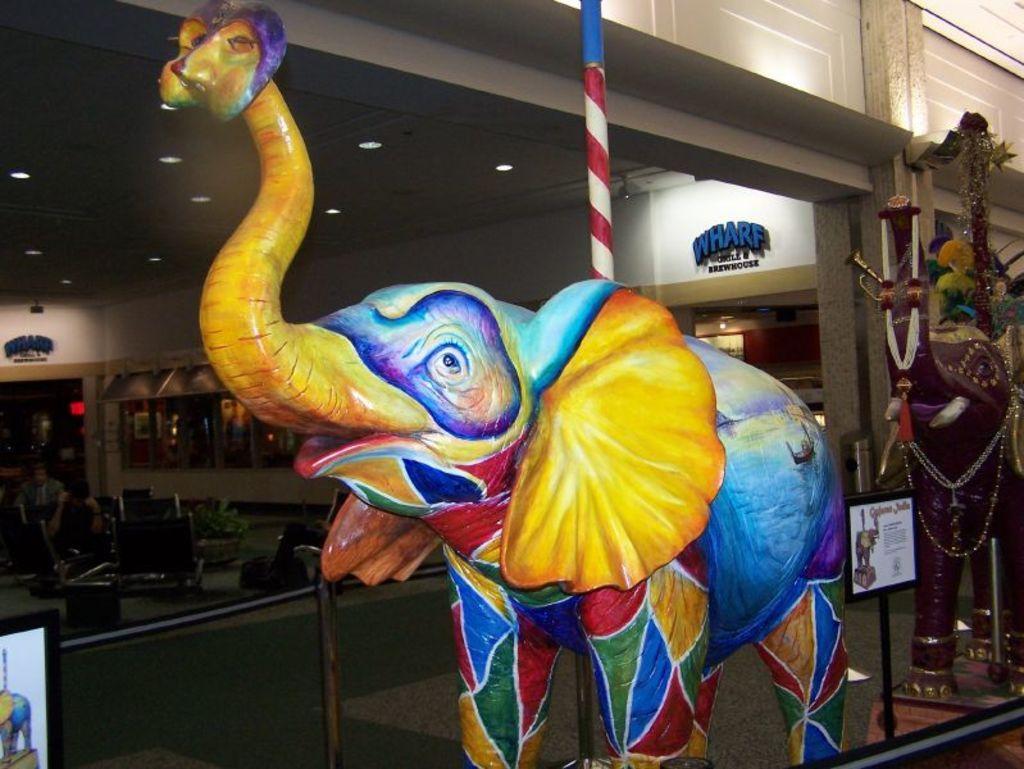Describe this image in one or two sentences. In this picture we can see a statue of an elephant near to the fencing. On the left we can see black elephant statue near to the pillar. In the back we can see windows, sign boards, plant and other objects. On the bottom left corner there is a painting. 